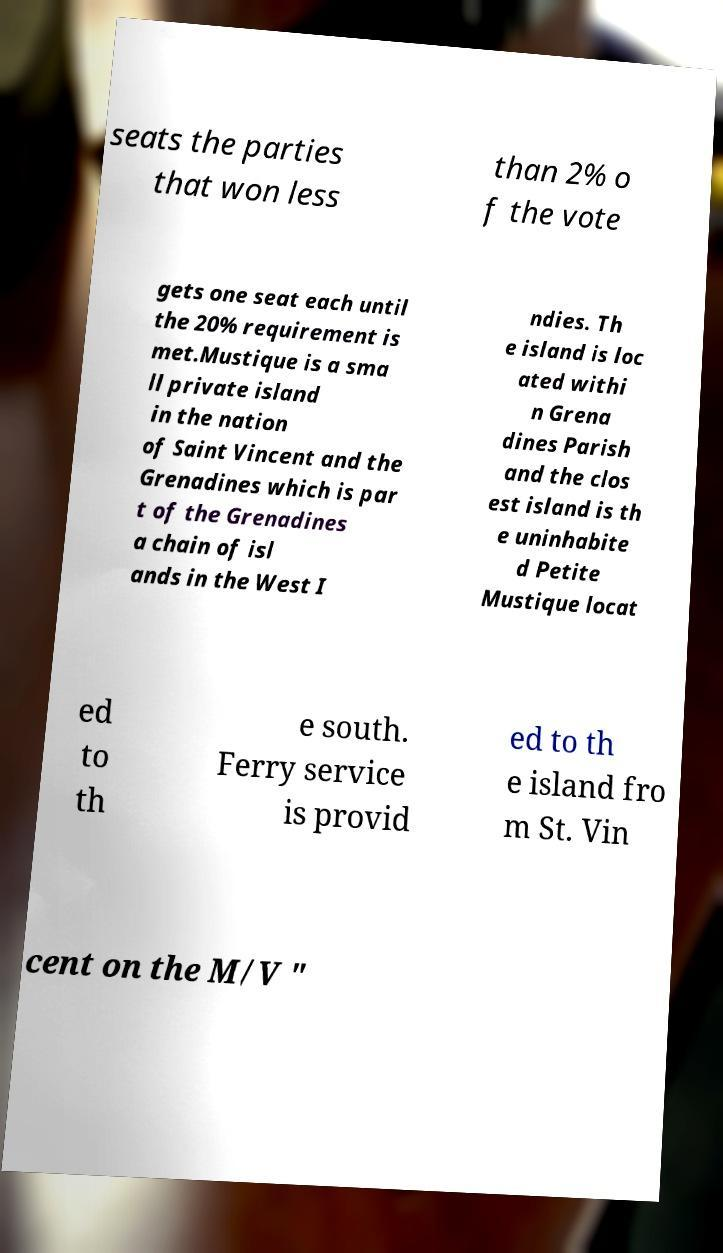What messages or text are displayed in this image? I need them in a readable, typed format. seats the parties that won less than 2% o f the vote gets one seat each until the 20% requirement is met.Mustique is a sma ll private island in the nation of Saint Vincent and the Grenadines which is par t of the Grenadines a chain of isl ands in the West I ndies. Th e island is loc ated withi n Grena dines Parish and the clos est island is th e uninhabite d Petite Mustique locat ed to th e south. Ferry service is provid ed to th e island fro m St. Vin cent on the M/V " 